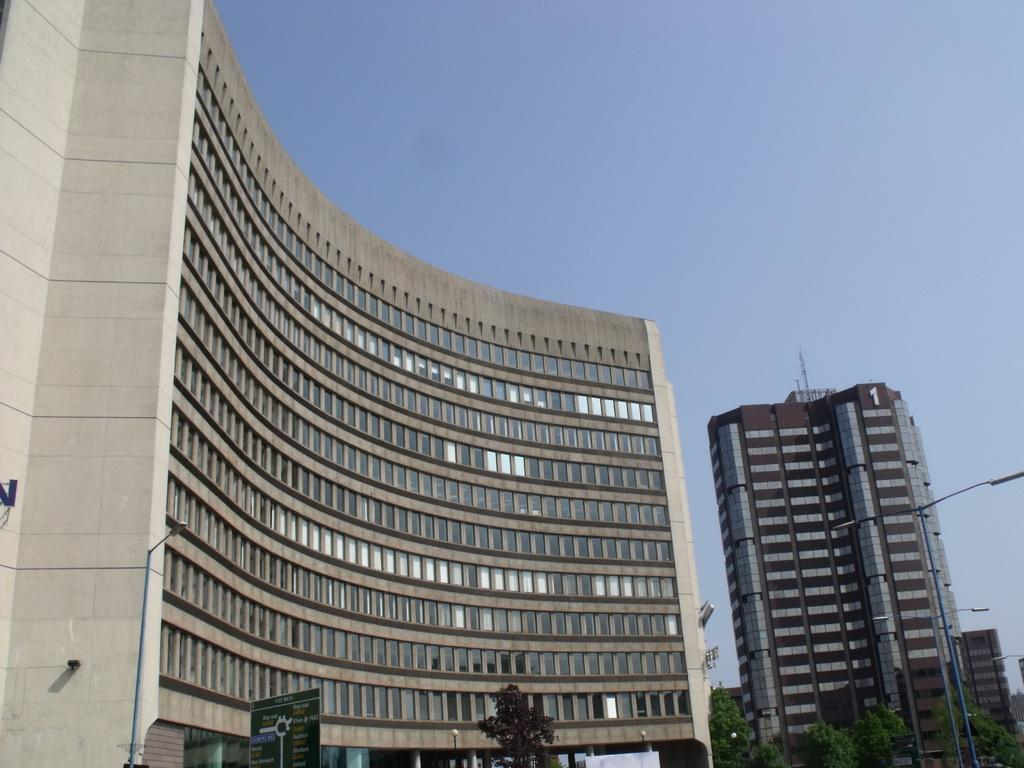What type of building is visible in the image? There is a building with glass windows in the image. What is located near the building? The building is near a tree. What can be seen on the building in the image? There is a hoarding on the building. What is visible in the background of the image? Trees and buildings are visible in the background of the image. What is the color of the sky in the image? The sky is blue in the image. Can you tell me what time the clock on the building shows in the image? There is no clock visible on the building in the image. What type of pleasure can be seen being experienced by the icicle in the image? There is no icicle present in the image. 